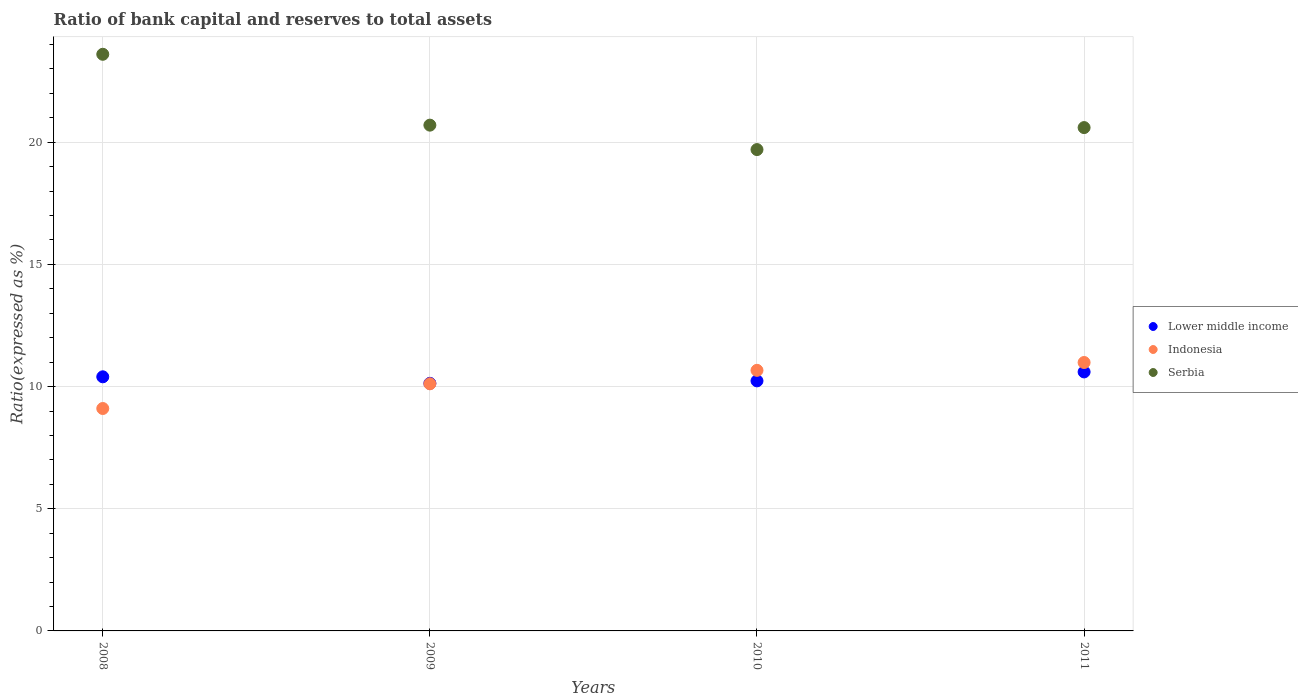How many different coloured dotlines are there?
Offer a very short reply. 3. What is the ratio of bank capital and reserves to total assets in Lower middle income in 2009?
Your response must be concise. 10.13. Across all years, what is the maximum ratio of bank capital and reserves to total assets in Lower middle income?
Make the answer very short. 10.6. Across all years, what is the minimum ratio of bank capital and reserves to total assets in Lower middle income?
Keep it short and to the point. 10.13. What is the total ratio of bank capital and reserves to total assets in Lower middle income in the graph?
Make the answer very short. 41.37. What is the difference between the ratio of bank capital and reserves to total assets in Serbia in 2010 and that in 2011?
Ensure brevity in your answer.  -0.9. What is the difference between the ratio of bank capital and reserves to total assets in Indonesia in 2008 and the ratio of bank capital and reserves to total assets in Lower middle income in 2009?
Your answer should be very brief. -1.03. What is the average ratio of bank capital and reserves to total assets in Serbia per year?
Give a very brief answer. 21.15. In the year 2008, what is the difference between the ratio of bank capital and reserves to total assets in Serbia and ratio of bank capital and reserves to total assets in Indonesia?
Keep it short and to the point. 14.5. What is the ratio of the ratio of bank capital and reserves to total assets in Indonesia in 2009 to that in 2010?
Your response must be concise. 0.95. What is the difference between the highest and the second highest ratio of bank capital and reserves to total assets in Indonesia?
Offer a very short reply. 0.32. What is the difference between the highest and the lowest ratio of bank capital and reserves to total assets in Indonesia?
Provide a short and direct response. 1.88. In how many years, is the ratio of bank capital and reserves to total assets in Indonesia greater than the average ratio of bank capital and reserves to total assets in Indonesia taken over all years?
Your answer should be very brief. 2. Is it the case that in every year, the sum of the ratio of bank capital and reserves to total assets in Lower middle income and ratio of bank capital and reserves to total assets in Serbia  is greater than the ratio of bank capital and reserves to total assets in Indonesia?
Your answer should be compact. Yes. Does the ratio of bank capital and reserves to total assets in Serbia monotonically increase over the years?
Provide a succinct answer. No. Are the values on the major ticks of Y-axis written in scientific E-notation?
Provide a short and direct response. No. How many legend labels are there?
Ensure brevity in your answer.  3. How are the legend labels stacked?
Your answer should be very brief. Vertical. What is the title of the graph?
Provide a short and direct response. Ratio of bank capital and reserves to total assets. Does "Dominican Republic" appear as one of the legend labels in the graph?
Your answer should be compact. No. What is the label or title of the Y-axis?
Provide a succinct answer. Ratio(expressed as %). What is the Ratio(expressed as %) of Lower middle income in 2008?
Your answer should be very brief. 10.4. What is the Ratio(expressed as %) in Indonesia in 2008?
Offer a very short reply. 9.1. What is the Ratio(expressed as %) of Serbia in 2008?
Your answer should be very brief. 23.6. What is the Ratio(expressed as %) in Lower middle income in 2009?
Ensure brevity in your answer.  10.13. What is the Ratio(expressed as %) of Indonesia in 2009?
Your answer should be very brief. 10.11. What is the Ratio(expressed as %) in Serbia in 2009?
Your answer should be compact. 20.7. What is the Ratio(expressed as %) of Lower middle income in 2010?
Your response must be concise. 10.23. What is the Ratio(expressed as %) of Indonesia in 2010?
Provide a succinct answer. 10.66. What is the Ratio(expressed as %) of Serbia in 2010?
Your response must be concise. 19.7. What is the Ratio(expressed as %) in Lower middle income in 2011?
Offer a very short reply. 10.6. What is the Ratio(expressed as %) in Indonesia in 2011?
Your answer should be compact. 10.99. What is the Ratio(expressed as %) of Serbia in 2011?
Your response must be concise. 20.6. Across all years, what is the maximum Ratio(expressed as %) in Indonesia?
Make the answer very short. 10.99. Across all years, what is the maximum Ratio(expressed as %) of Serbia?
Provide a succinct answer. 23.6. Across all years, what is the minimum Ratio(expressed as %) in Lower middle income?
Provide a succinct answer. 10.13. Across all years, what is the minimum Ratio(expressed as %) of Indonesia?
Make the answer very short. 9.1. Across all years, what is the minimum Ratio(expressed as %) in Serbia?
Give a very brief answer. 19.7. What is the total Ratio(expressed as %) in Lower middle income in the graph?
Your answer should be compact. 41.37. What is the total Ratio(expressed as %) of Indonesia in the graph?
Your response must be concise. 40.87. What is the total Ratio(expressed as %) of Serbia in the graph?
Ensure brevity in your answer.  84.6. What is the difference between the Ratio(expressed as %) in Lower middle income in 2008 and that in 2009?
Provide a short and direct response. 0.27. What is the difference between the Ratio(expressed as %) of Indonesia in 2008 and that in 2009?
Offer a very short reply. -1.01. What is the difference between the Ratio(expressed as %) of Lower middle income in 2008 and that in 2010?
Keep it short and to the point. 0.17. What is the difference between the Ratio(expressed as %) of Indonesia in 2008 and that in 2010?
Offer a terse response. -1.56. What is the difference between the Ratio(expressed as %) in Serbia in 2008 and that in 2010?
Ensure brevity in your answer.  3.9. What is the difference between the Ratio(expressed as %) of Lower middle income in 2008 and that in 2011?
Give a very brief answer. -0.2. What is the difference between the Ratio(expressed as %) in Indonesia in 2008 and that in 2011?
Your response must be concise. -1.88. What is the difference between the Ratio(expressed as %) in Lower middle income in 2009 and that in 2010?
Your answer should be compact. -0.1. What is the difference between the Ratio(expressed as %) of Indonesia in 2009 and that in 2010?
Provide a succinct answer. -0.55. What is the difference between the Ratio(expressed as %) of Serbia in 2009 and that in 2010?
Give a very brief answer. 1. What is the difference between the Ratio(expressed as %) of Lower middle income in 2009 and that in 2011?
Give a very brief answer. -0.47. What is the difference between the Ratio(expressed as %) in Indonesia in 2009 and that in 2011?
Give a very brief answer. -0.87. What is the difference between the Ratio(expressed as %) in Serbia in 2009 and that in 2011?
Your answer should be compact. 0.1. What is the difference between the Ratio(expressed as %) in Lower middle income in 2010 and that in 2011?
Your answer should be very brief. -0.37. What is the difference between the Ratio(expressed as %) of Indonesia in 2010 and that in 2011?
Your response must be concise. -0.32. What is the difference between the Ratio(expressed as %) of Serbia in 2010 and that in 2011?
Make the answer very short. -0.9. What is the difference between the Ratio(expressed as %) in Lower middle income in 2008 and the Ratio(expressed as %) in Indonesia in 2009?
Provide a succinct answer. 0.29. What is the difference between the Ratio(expressed as %) of Lower middle income in 2008 and the Ratio(expressed as %) of Serbia in 2009?
Ensure brevity in your answer.  -10.3. What is the difference between the Ratio(expressed as %) in Indonesia in 2008 and the Ratio(expressed as %) in Serbia in 2009?
Give a very brief answer. -11.6. What is the difference between the Ratio(expressed as %) in Lower middle income in 2008 and the Ratio(expressed as %) in Indonesia in 2010?
Your answer should be very brief. -0.26. What is the difference between the Ratio(expressed as %) in Lower middle income in 2008 and the Ratio(expressed as %) in Serbia in 2010?
Your answer should be very brief. -9.3. What is the difference between the Ratio(expressed as %) of Indonesia in 2008 and the Ratio(expressed as %) of Serbia in 2010?
Provide a succinct answer. -10.6. What is the difference between the Ratio(expressed as %) of Lower middle income in 2008 and the Ratio(expressed as %) of Indonesia in 2011?
Your response must be concise. -0.59. What is the difference between the Ratio(expressed as %) of Indonesia in 2008 and the Ratio(expressed as %) of Serbia in 2011?
Provide a succinct answer. -11.5. What is the difference between the Ratio(expressed as %) in Lower middle income in 2009 and the Ratio(expressed as %) in Indonesia in 2010?
Your response must be concise. -0.53. What is the difference between the Ratio(expressed as %) in Lower middle income in 2009 and the Ratio(expressed as %) in Serbia in 2010?
Your response must be concise. -9.57. What is the difference between the Ratio(expressed as %) in Indonesia in 2009 and the Ratio(expressed as %) in Serbia in 2010?
Provide a succinct answer. -9.59. What is the difference between the Ratio(expressed as %) of Lower middle income in 2009 and the Ratio(expressed as %) of Indonesia in 2011?
Offer a terse response. -0.85. What is the difference between the Ratio(expressed as %) in Lower middle income in 2009 and the Ratio(expressed as %) in Serbia in 2011?
Ensure brevity in your answer.  -10.47. What is the difference between the Ratio(expressed as %) in Indonesia in 2009 and the Ratio(expressed as %) in Serbia in 2011?
Keep it short and to the point. -10.49. What is the difference between the Ratio(expressed as %) in Lower middle income in 2010 and the Ratio(expressed as %) in Indonesia in 2011?
Your answer should be compact. -0.75. What is the difference between the Ratio(expressed as %) in Lower middle income in 2010 and the Ratio(expressed as %) in Serbia in 2011?
Your response must be concise. -10.37. What is the difference between the Ratio(expressed as %) of Indonesia in 2010 and the Ratio(expressed as %) of Serbia in 2011?
Keep it short and to the point. -9.94. What is the average Ratio(expressed as %) of Lower middle income per year?
Offer a terse response. 10.34. What is the average Ratio(expressed as %) in Indonesia per year?
Offer a very short reply. 10.22. What is the average Ratio(expressed as %) in Serbia per year?
Offer a terse response. 21.15. In the year 2008, what is the difference between the Ratio(expressed as %) of Lower middle income and Ratio(expressed as %) of Indonesia?
Offer a terse response. 1.3. In the year 2008, what is the difference between the Ratio(expressed as %) in Lower middle income and Ratio(expressed as %) in Serbia?
Your answer should be compact. -13.2. In the year 2008, what is the difference between the Ratio(expressed as %) of Indonesia and Ratio(expressed as %) of Serbia?
Ensure brevity in your answer.  -14.5. In the year 2009, what is the difference between the Ratio(expressed as %) of Lower middle income and Ratio(expressed as %) of Indonesia?
Your answer should be very brief. 0.02. In the year 2009, what is the difference between the Ratio(expressed as %) in Lower middle income and Ratio(expressed as %) in Serbia?
Your answer should be compact. -10.57. In the year 2009, what is the difference between the Ratio(expressed as %) in Indonesia and Ratio(expressed as %) in Serbia?
Offer a very short reply. -10.59. In the year 2010, what is the difference between the Ratio(expressed as %) of Lower middle income and Ratio(expressed as %) of Indonesia?
Your answer should be compact. -0.43. In the year 2010, what is the difference between the Ratio(expressed as %) of Lower middle income and Ratio(expressed as %) of Serbia?
Offer a very short reply. -9.47. In the year 2010, what is the difference between the Ratio(expressed as %) in Indonesia and Ratio(expressed as %) in Serbia?
Offer a terse response. -9.04. In the year 2011, what is the difference between the Ratio(expressed as %) in Lower middle income and Ratio(expressed as %) in Indonesia?
Provide a succinct answer. -0.39. In the year 2011, what is the difference between the Ratio(expressed as %) in Lower middle income and Ratio(expressed as %) in Serbia?
Make the answer very short. -10. In the year 2011, what is the difference between the Ratio(expressed as %) in Indonesia and Ratio(expressed as %) in Serbia?
Make the answer very short. -9.61. What is the ratio of the Ratio(expressed as %) of Lower middle income in 2008 to that in 2009?
Make the answer very short. 1.03. What is the ratio of the Ratio(expressed as %) of Indonesia in 2008 to that in 2009?
Ensure brevity in your answer.  0.9. What is the ratio of the Ratio(expressed as %) in Serbia in 2008 to that in 2009?
Keep it short and to the point. 1.14. What is the ratio of the Ratio(expressed as %) of Lower middle income in 2008 to that in 2010?
Give a very brief answer. 1.02. What is the ratio of the Ratio(expressed as %) in Indonesia in 2008 to that in 2010?
Your answer should be very brief. 0.85. What is the ratio of the Ratio(expressed as %) of Serbia in 2008 to that in 2010?
Your answer should be very brief. 1.2. What is the ratio of the Ratio(expressed as %) of Lower middle income in 2008 to that in 2011?
Provide a short and direct response. 0.98. What is the ratio of the Ratio(expressed as %) in Indonesia in 2008 to that in 2011?
Your response must be concise. 0.83. What is the ratio of the Ratio(expressed as %) in Serbia in 2008 to that in 2011?
Your response must be concise. 1.15. What is the ratio of the Ratio(expressed as %) in Lower middle income in 2009 to that in 2010?
Make the answer very short. 0.99. What is the ratio of the Ratio(expressed as %) of Indonesia in 2009 to that in 2010?
Provide a succinct answer. 0.95. What is the ratio of the Ratio(expressed as %) of Serbia in 2009 to that in 2010?
Offer a very short reply. 1.05. What is the ratio of the Ratio(expressed as %) in Lower middle income in 2009 to that in 2011?
Provide a short and direct response. 0.96. What is the ratio of the Ratio(expressed as %) of Indonesia in 2009 to that in 2011?
Your answer should be very brief. 0.92. What is the ratio of the Ratio(expressed as %) in Lower middle income in 2010 to that in 2011?
Your response must be concise. 0.97. What is the ratio of the Ratio(expressed as %) in Indonesia in 2010 to that in 2011?
Make the answer very short. 0.97. What is the ratio of the Ratio(expressed as %) of Serbia in 2010 to that in 2011?
Ensure brevity in your answer.  0.96. What is the difference between the highest and the second highest Ratio(expressed as %) in Lower middle income?
Your response must be concise. 0.2. What is the difference between the highest and the second highest Ratio(expressed as %) in Indonesia?
Make the answer very short. 0.32. What is the difference between the highest and the lowest Ratio(expressed as %) of Lower middle income?
Give a very brief answer. 0.47. What is the difference between the highest and the lowest Ratio(expressed as %) in Indonesia?
Make the answer very short. 1.88. What is the difference between the highest and the lowest Ratio(expressed as %) of Serbia?
Give a very brief answer. 3.9. 